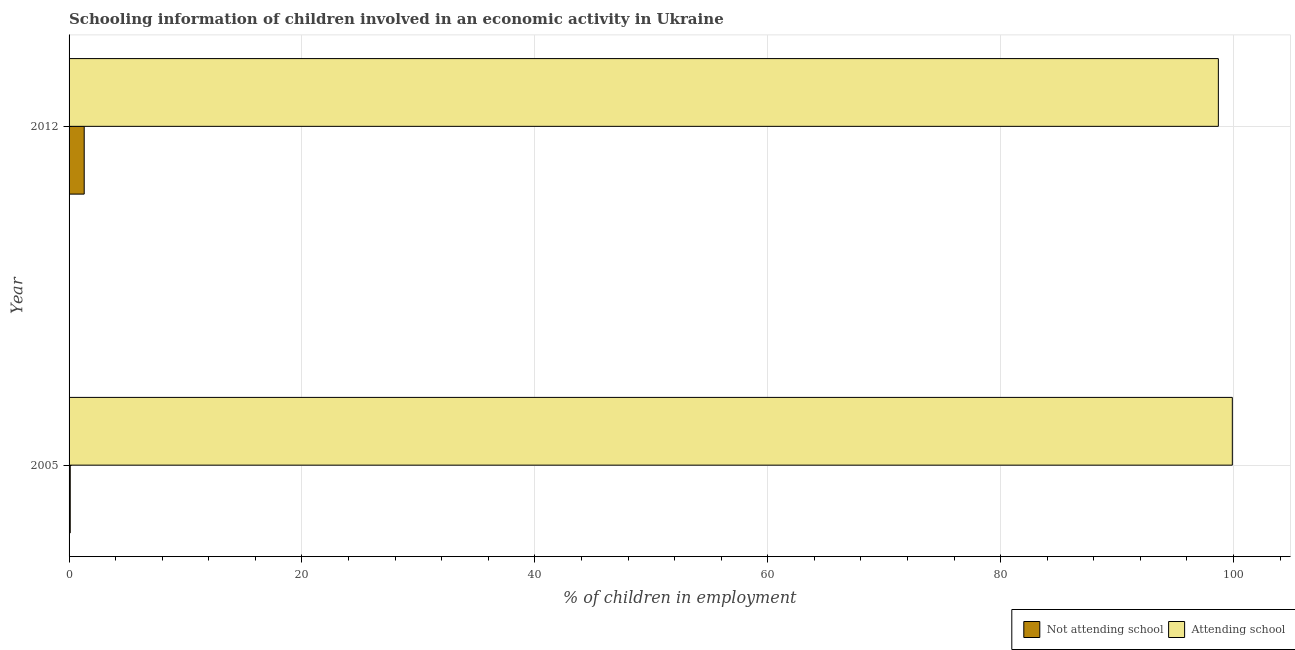How many different coloured bars are there?
Your answer should be compact. 2. Are the number of bars per tick equal to the number of legend labels?
Your answer should be very brief. Yes. Are the number of bars on each tick of the Y-axis equal?
Provide a succinct answer. Yes. How many bars are there on the 1st tick from the top?
Ensure brevity in your answer.  2. How many bars are there on the 2nd tick from the bottom?
Ensure brevity in your answer.  2. In how many cases, is the number of bars for a given year not equal to the number of legend labels?
Offer a terse response. 0. What is the percentage of employed children who are attending school in 2012?
Keep it short and to the point. 98.7. Across all years, what is the minimum percentage of employed children who are attending school?
Your answer should be very brief. 98.7. In which year was the percentage of employed children who are attending school minimum?
Your response must be concise. 2012. What is the total percentage of employed children who are attending school in the graph?
Provide a succinct answer. 198.6. What is the difference between the percentage of employed children who are not attending school in 2005 and that in 2012?
Provide a succinct answer. -1.2. What is the difference between the percentage of employed children who are not attending school in 2005 and the percentage of employed children who are attending school in 2012?
Make the answer very short. -98.6. What is the average percentage of employed children who are attending school per year?
Ensure brevity in your answer.  99.3. In the year 2005, what is the difference between the percentage of employed children who are attending school and percentage of employed children who are not attending school?
Your answer should be very brief. 99.8. What is the ratio of the percentage of employed children who are attending school in 2005 to that in 2012?
Your response must be concise. 1.01. In how many years, is the percentage of employed children who are attending school greater than the average percentage of employed children who are attending school taken over all years?
Offer a terse response. 1. What does the 2nd bar from the top in 2005 represents?
Ensure brevity in your answer.  Not attending school. What does the 1st bar from the bottom in 2012 represents?
Offer a terse response. Not attending school. How many bars are there?
Provide a short and direct response. 4. What is the difference between two consecutive major ticks on the X-axis?
Provide a succinct answer. 20. Are the values on the major ticks of X-axis written in scientific E-notation?
Provide a succinct answer. No. Does the graph contain grids?
Give a very brief answer. Yes. Where does the legend appear in the graph?
Offer a terse response. Bottom right. What is the title of the graph?
Your response must be concise. Schooling information of children involved in an economic activity in Ukraine. Does "Savings" appear as one of the legend labels in the graph?
Your response must be concise. No. What is the label or title of the X-axis?
Your answer should be very brief. % of children in employment. What is the % of children in employment in Attending school in 2005?
Your answer should be compact. 99.9. What is the % of children in employment in Not attending school in 2012?
Keep it short and to the point. 1.3. What is the % of children in employment of Attending school in 2012?
Give a very brief answer. 98.7. Across all years, what is the maximum % of children in employment in Not attending school?
Ensure brevity in your answer.  1.3. Across all years, what is the maximum % of children in employment of Attending school?
Keep it short and to the point. 99.9. Across all years, what is the minimum % of children in employment of Not attending school?
Your response must be concise. 0.1. Across all years, what is the minimum % of children in employment in Attending school?
Your answer should be compact. 98.7. What is the total % of children in employment in Attending school in the graph?
Your response must be concise. 198.6. What is the difference between the % of children in employment in Attending school in 2005 and that in 2012?
Your answer should be very brief. 1.2. What is the difference between the % of children in employment of Not attending school in 2005 and the % of children in employment of Attending school in 2012?
Offer a terse response. -98.6. What is the average % of children in employment in Not attending school per year?
Offer a very short reply. 0.7. What is the average % of children in employment in Attending school per year?
Offer a very short reply. 99.3. In the year 2005, what is the difference between the % of children in employment of Not attending school and % of children in employment of Attending school?
Keep it short and to the point. -99.8. In the year 2012, what is the difference between the % of children in employment in Not attending school and % of children in employment in Attending school?
Give a very brief answer. -97.4. What is the ratio of the % of children in employment in Not attending school in 2005 to that in 2012?
Your answer should be compact. 0.08. What is the ratio of the % of children in employment in Attending school in 2005 to that in 2012?
Ensure brevity in your answer.  1.01. What is the difference between the highest and the second highest % of children in employment of Attending school?
Ensure brevity in your answer.  1.2. What is the difference between the highest and the lowest % of children in employment in Attending school?
Ensure brevity in your answer.  1.2. 